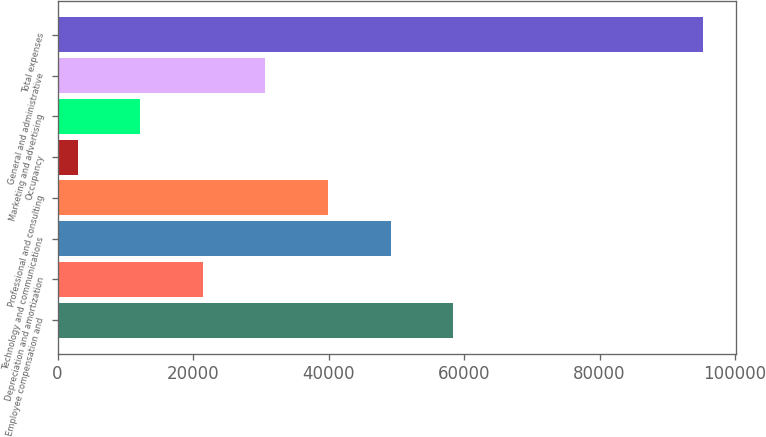<chart> <loc_0><loc_0><loc_500><loc_500><bar_chart><fcel>Employee compensation and<fcel>Depreciation and amortization<fcel>Technology and communications<fcel>Professional and consulting<fcel>Occupancy<fcel>Marketing and advertising<fcel>General and administrative<fcel>Total expenses<nl><fcel>58389.6<fcel>21461.2<fcel>49157.5<fcel>39925.4<fcel>2997<fcel>12229.1<fcel>30693.3<fcel>95318<nl></chart> 